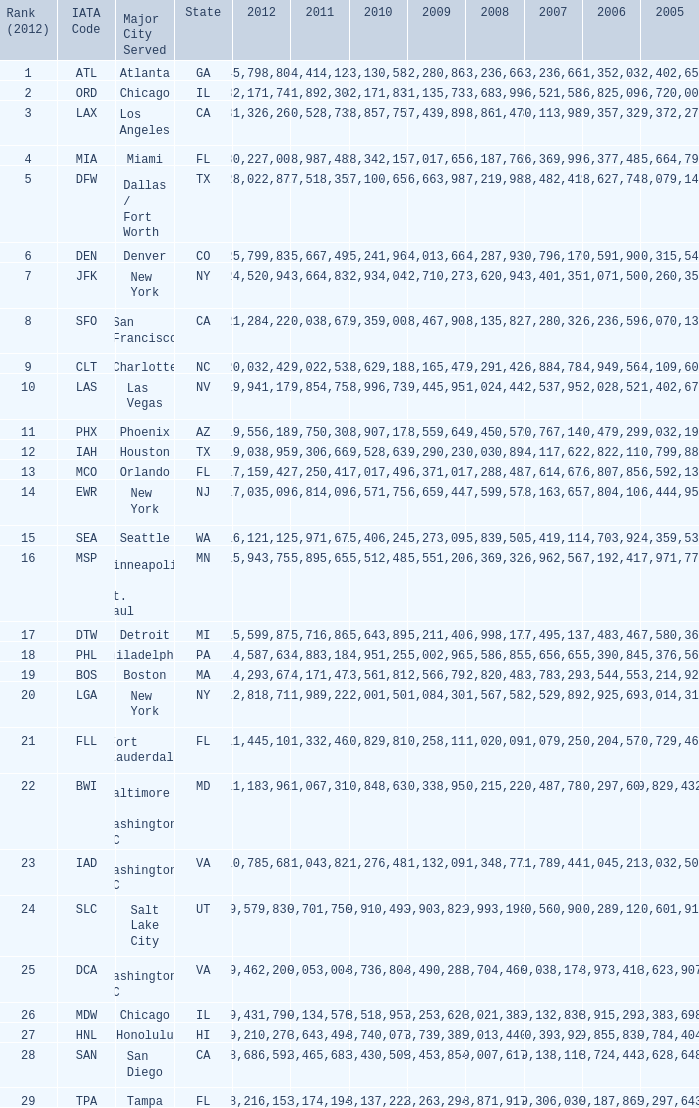For the IATA code of lax with 2009 less than 31,135,732 and 2011 less than 8,174,194, what is the sum of 2012? 0.0. 